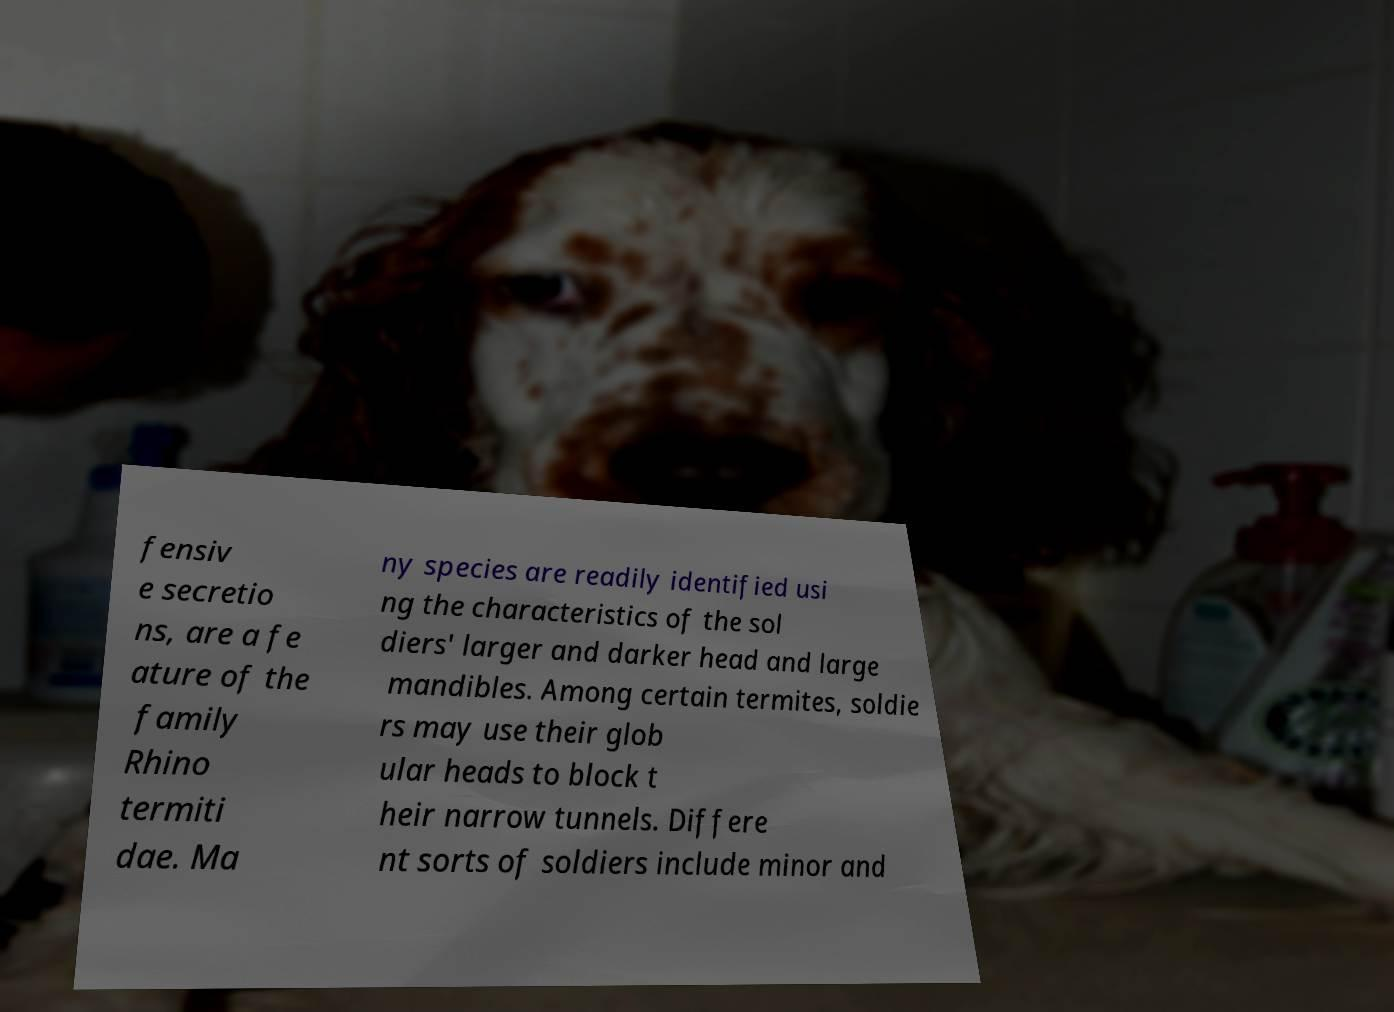Can you accurately transcribe the text from the provided image for me? fensiv e secretio ns, are a fe ature of the family Rhino termiti dae. Ma ny species are readily identified usi ng the characteristics of the sol diers' larger and darker head and large mandibles. Among certain termites, soldie rs may use their glob ular heads to block t heir narrow tunnels. Differe nt sorts of soldiers include minor and 